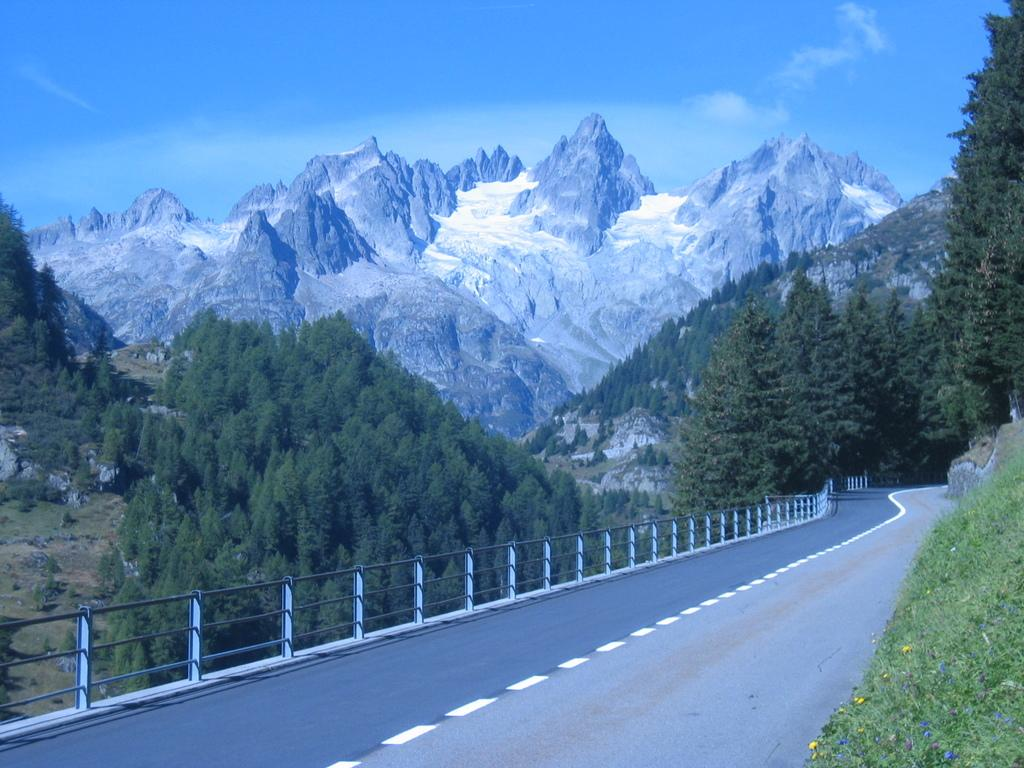What is the main feature of the image? There is a road in the image. What can be seen alongside the road? There is fencing in the image. What type of vegetation is on the right side of the image? Plants are present on the right side of the image. What is visible in the background of the image? There are mountains and trees in the background of the image. What is the color of the sky in the image? The sky is blue in color. Where is the flock of birds flying in the image? There are no birds or flock visible in the image. What type of ship can be seen sailing in the background of the image? There is no ship present in the image; it features a road, fencing, plants, mountains, trees, and a blue sky. 